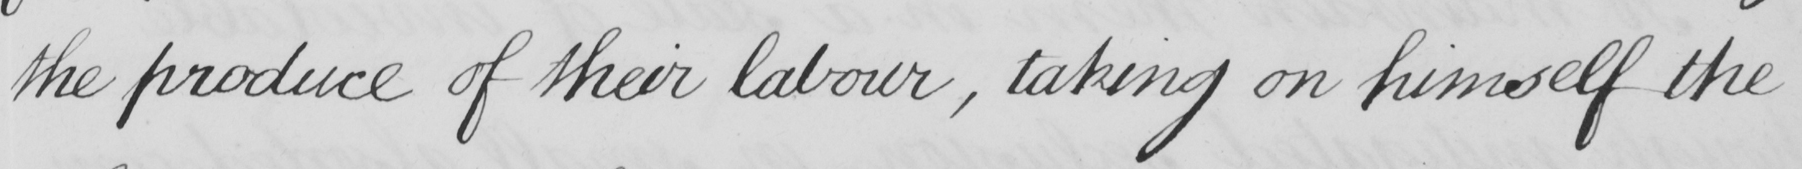What text is written in this handwritten line? the produce of their labour , taking on himself the 